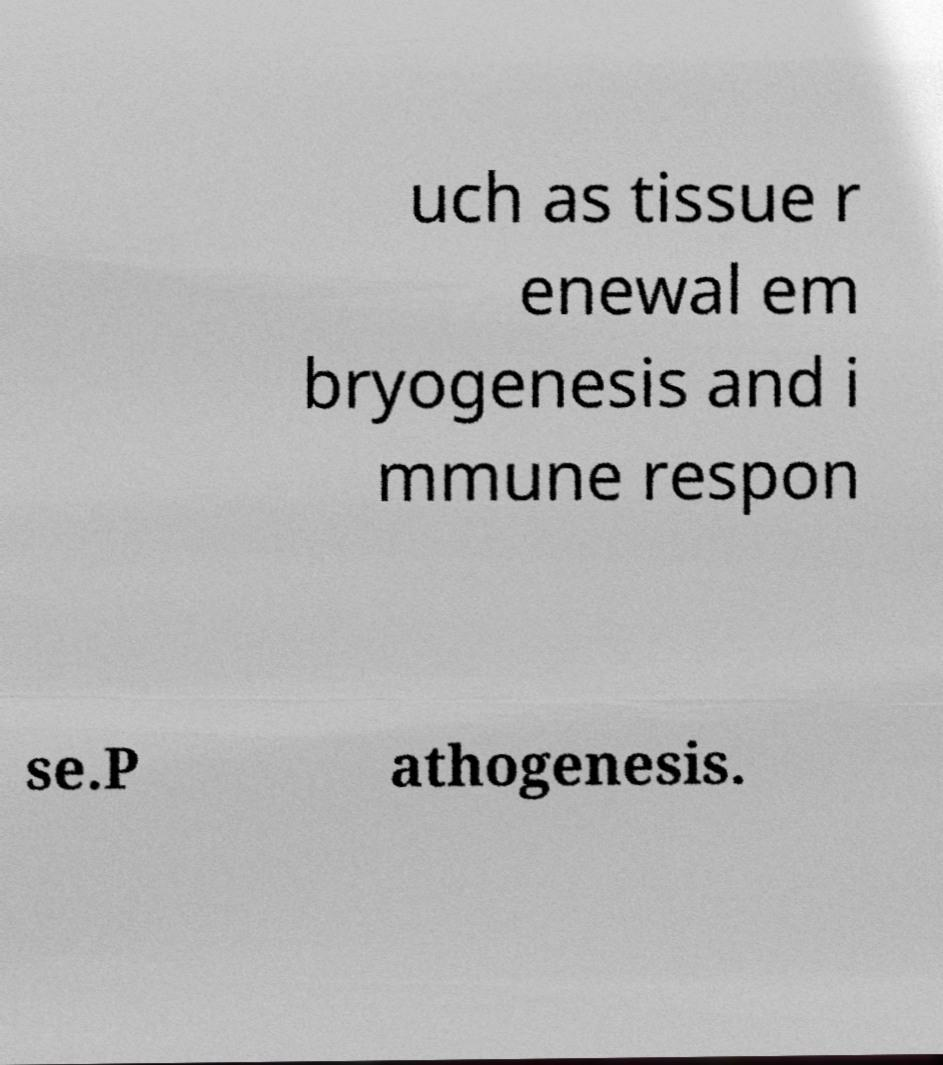Could you extract and type out the text from this image? uch as tissue r enewal em bryogenesis and i mmune respon se.P athogenesis. 